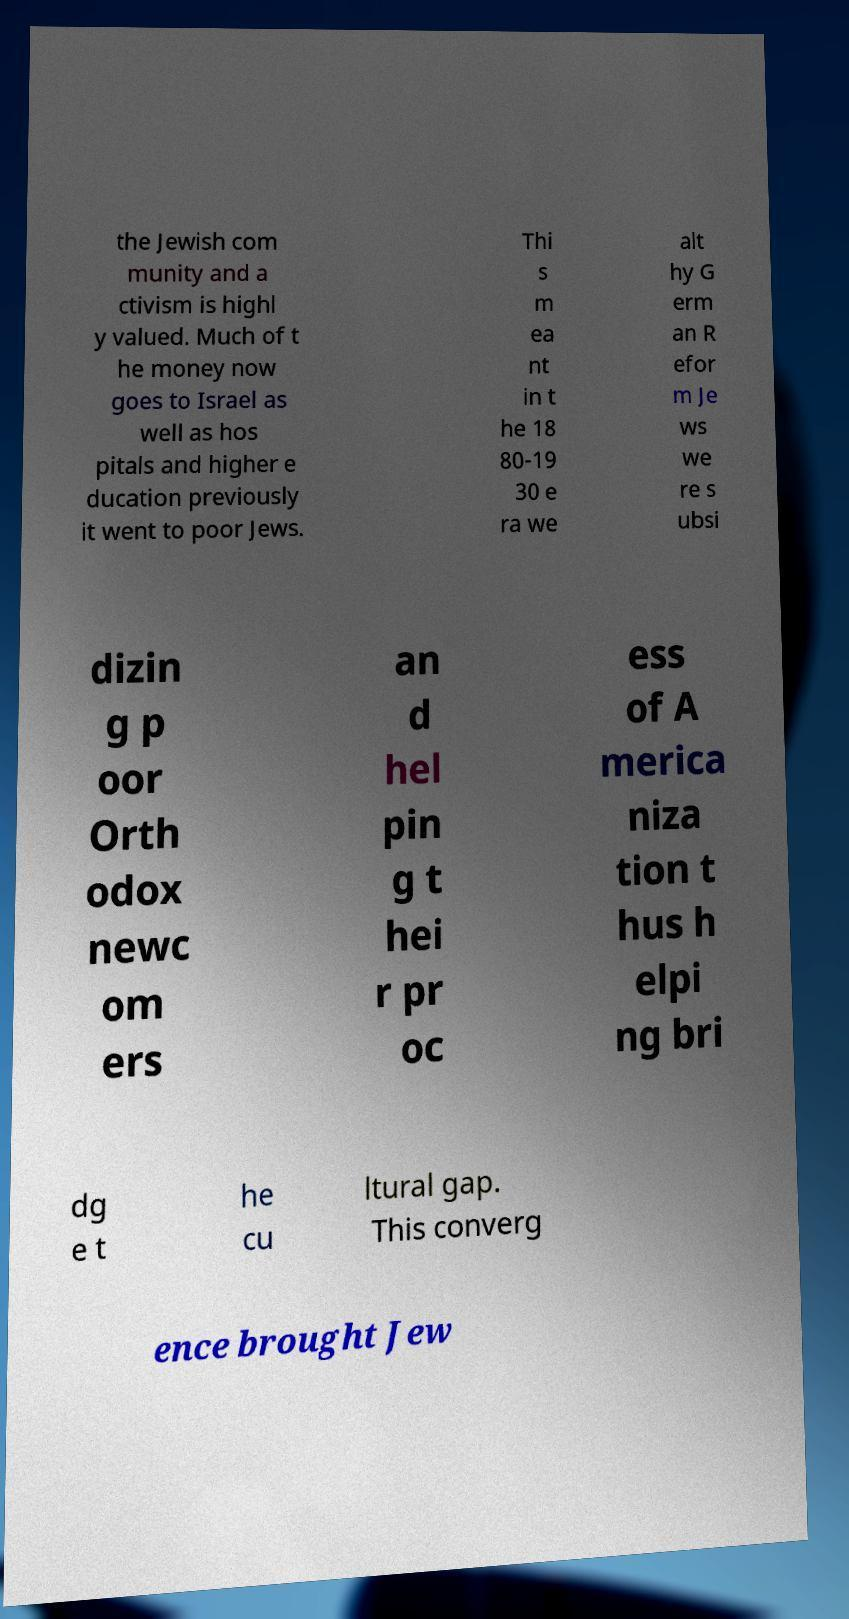For documentation purposes, I need the text within this image transcribed. Could you provide that? the Jewish com munity and a ctivism is highl y valued. Much of t he money now goes to Israel as well as hos pitals and higher e ducation previously it went to poor Jews. Thi s m ea nt in t he 18 80-19 30 e ra we alt hy G erm an R efor m Je ws we re s ubsi dizin g p oor Orth odox newc om ers an d hel pin g t hei r pr oc ess of A merica niza tion t hus h elpi ng bri dg e t he cu ltural gap. This converg ence brought Jew 